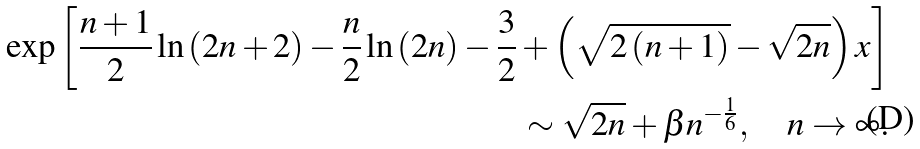Convert formula to latex. <formula><loc_0><loc_0><loc_500><loc_500>\exp \left [ \frac { n + 1 } { 2 } \ln \left ( 2 n + 2 \right ) - \frac { n } { 2 } \ln \left ( 2 n \right ) - \frac { 3 } { 2 } + \left ( \sqrt { 2 \left ( n + 1 \right ) } - \sqrt { 2 n } \right ) x \right ] \\ \sim \sqrt { 2 n } + \beta n ^ { - \frac { 1 } { 6 } } , \quad n \rightarrow \infty .</formula> 